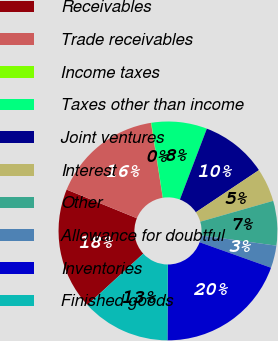<chart> <loc_0><loc_0><loc_500><loc_500><pie_chart><fcel>Receivables<fcel>Trade receivables<fcel>Income taxes<fcel>Taxes other than income<fcel>Joint ventures<fcel>Interest<fcel>Other<fcel>Allowance for doubtful<fcel>Inventories<fcel>Finished goods<nl><fcel>17.99%<fcel>16.36%<fcel>0.05%<fcel>8.21%<fcel>9.84%<fcel>4.95%<fcel>6.58%<fcel>3.31%<fcel>19.62%<fcel>13.1%<nl></chart> 